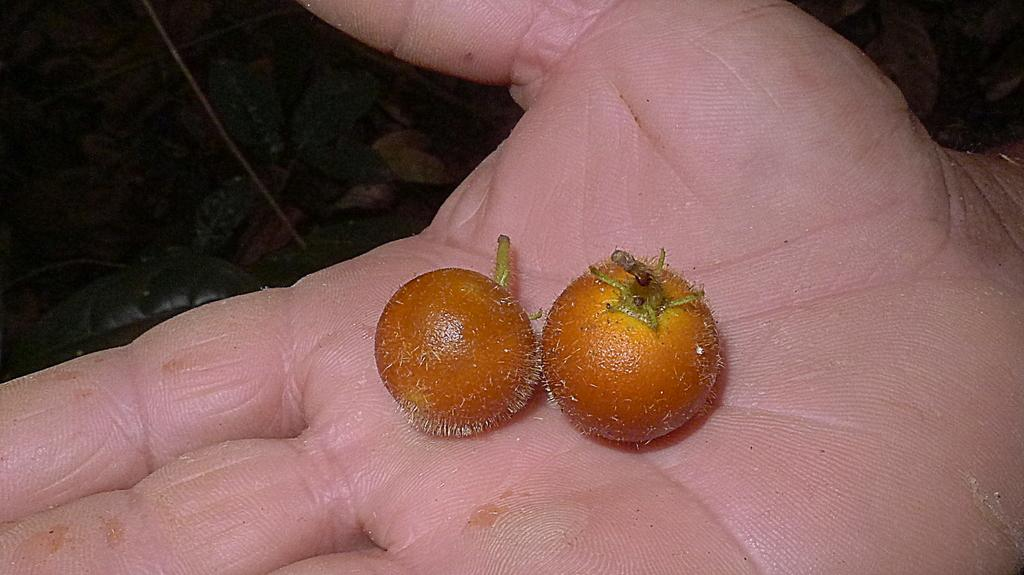What is the main subject of the image? The main subject of the image is a human hand. What is the hand holding in the image? There are objects in the hand in the image. What can be seen in the background of the image? The background of the image includes leaves. What type of prison can be seen in the background of the image? There is no prison present in the image; the background includes leaves. 